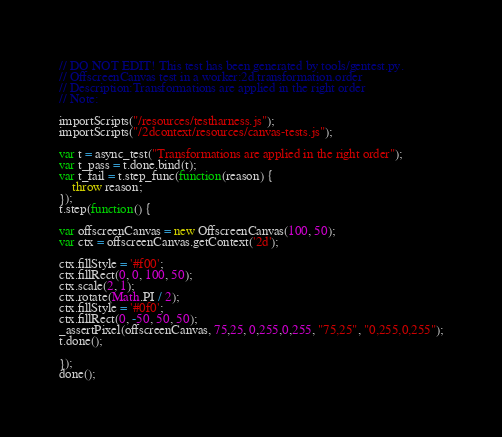Convert code to text. <code><loc_0><loc_0><loc_500><loc_500><_JavaScript_>// DO NOT EDIT! This test has been generated by tools/gentest.py.
// OffscreenCanvas test in a worker:2d.transformation.order
// Description:Transformations are applied in the right order
// Note:

importScripts("/resources/testharness.js");
importScripts("/2dcontext/resources/canvas-tests.js");

var t = async_test("Transformations are applied in the right order");
var t_pass = t.done.bind(t);
var t_fail = t.step_func(function(reason) {
    throw reason;
});
t.step(function() {

var offscreenCanvas = new OffscreenCanvas(100, 50);
var ctx = offscreenCanvas.getContext('2d');

ctx.fillStyle = '#f00';
ctx.fillRect(0, 0, 100, 50);
ctx.scale(2, 1);
ctx.rotate(Math.PI / 2);
ctx.fillStyle = '#0f0';
ctx.fillRect(0, -50, 50, 50);
_assertPixel(offscreenCanvas, 75,25, 0,255,0,255, "75,25", "0,255,0,255");
t.done();

});
done();
</code> 